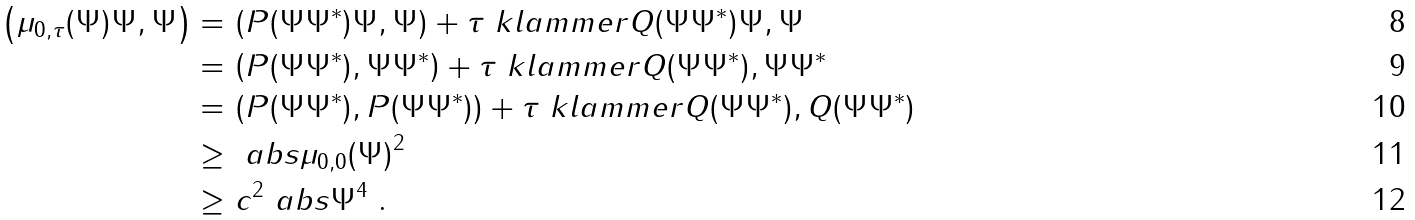<formula> <loc_0><loc_0><loc_500><loc_500>\left ( \mu _ { 0 , \tau } ( \Psi ) \Psi , \Psi \right ) = & \, \left ( P ( \Psi \Psi ^ { * } ) \Psi , \Psi \right ) + \tau \ k l a m m e r { Q ( \Psi \Psi ^ { * } ) \Psi , \Psi } \\ = & \, \left ( P ( \Psi \Psi ^ { * } ) , \Psi \Psi ^ { * } \right ) + \tau \ k l a m m e r { Q ( \Psi \Psi ^ { * } ) , \Psi \Psi ^ { * } } \\ = & \, \left ( P ( \Psi \Psi ^ { * } ) , P ( \Psi \Psi ^ { * } ) \right ) + \tau \ k l a m m e r { Q ( \Psi \Psi ^ { * } ) , Q ( \Psi \Psi ^ { * } ) } \\ \geq & \ \ a b s { \mu _ { 0 , 0 } ( \Psi ) } ^ { 2 } \\ \geq & \ c ^ { 2 } \ a b s { \Psi } ^ { 4 } \ .</formula> 